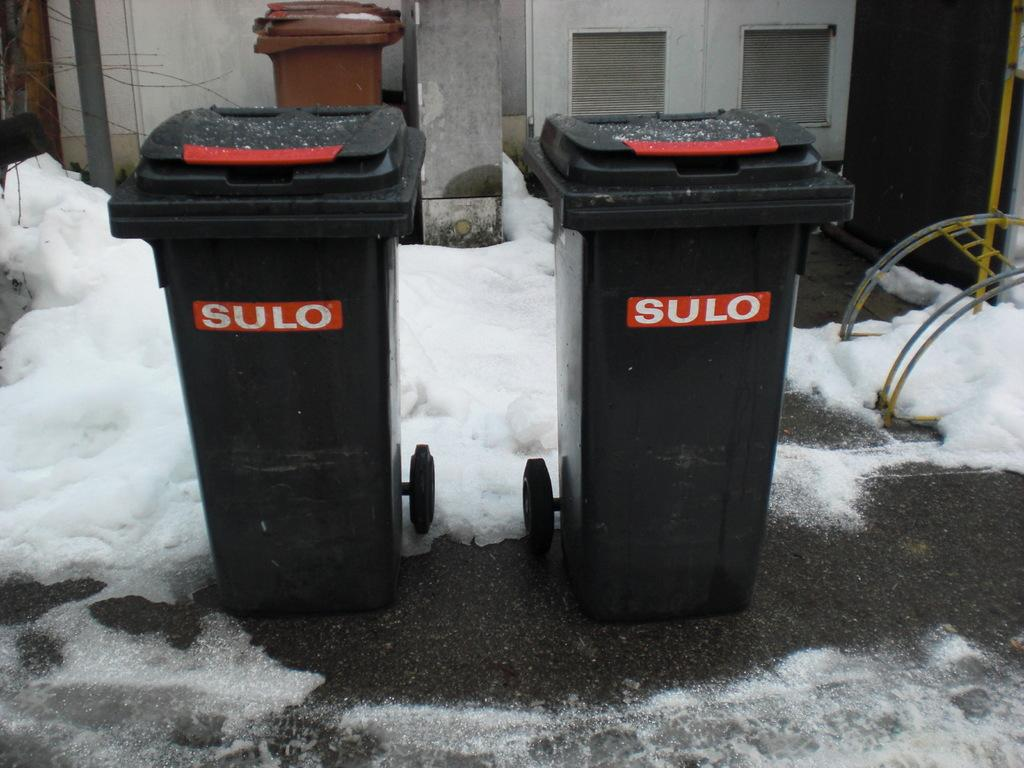<image>
Summarize the visual content of the image. Two dark grey bins with red SULO logos on them. 